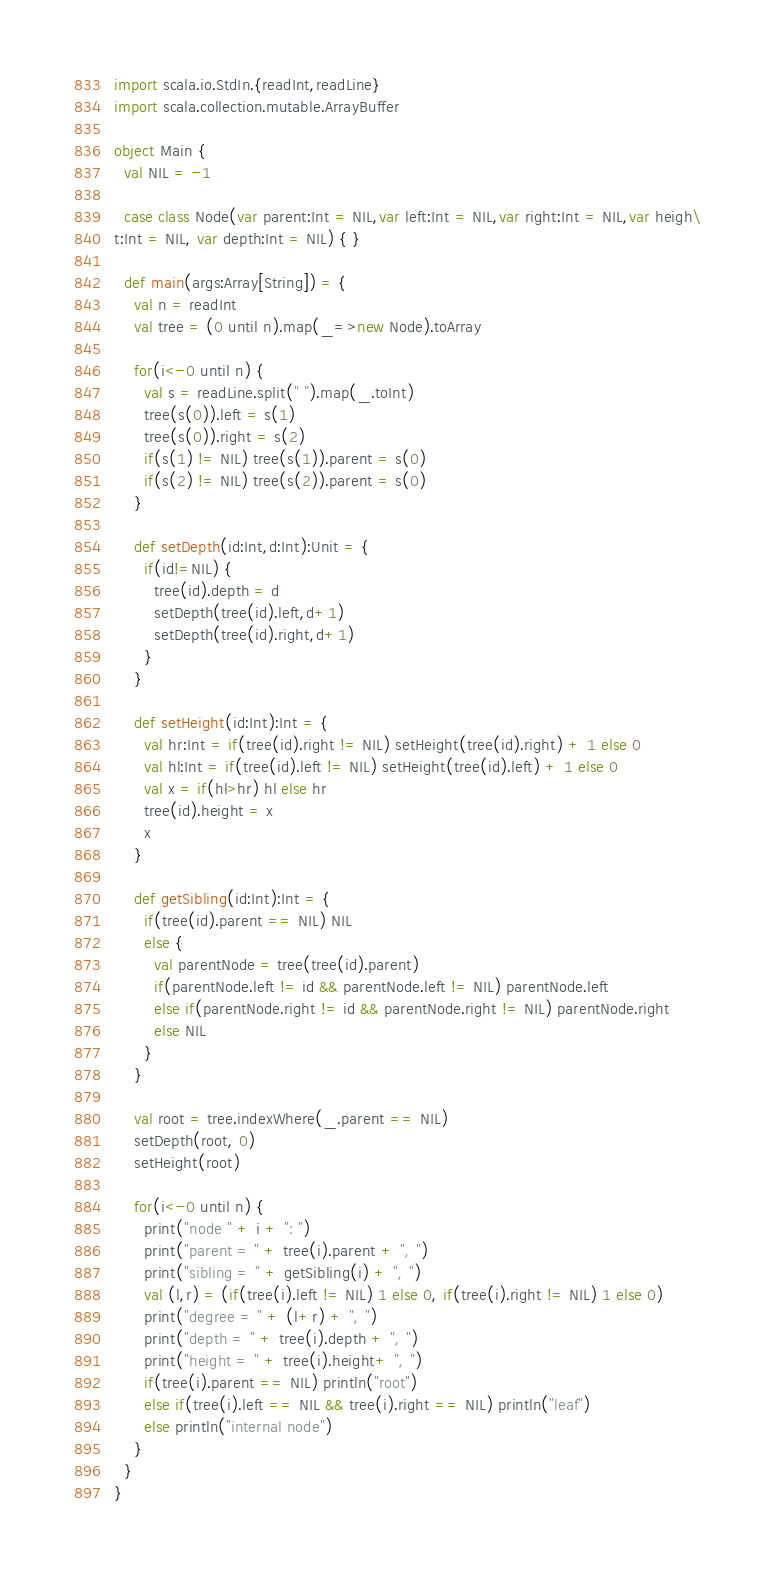Convert code to text. <code><loc_0><loc_0><loc_500><loc_500><_Scala_>import scala.io.StdIn.{readInt,readLine}
import scala.collection.mutable.ArrayBuffer

object Main {
  val NIL = -1

  case class Node(var parent:Int = NIL,var left:Int = NIL,var right:Int = NIL,var heigh\
t:Int = NIL, var depth:Int = NIL) { }

  def main(args:Array[String]) = {
    val n = readInt
    val tree = (0 until n).map(_=>new Node).toArray

    for(i<-0 until n) {
      val s = readLine.split(" ").map(_.toInt)
      tree(s(0)).left = s(1)
      tree(s(0)).right = s(2)
      if(s(1) != NIL) tree(s(1)).parent = s(0)
      if(s(2) != NIL) tree(s(2)).parent = s(0)
    }

    def setDepth(id:Int,d:Int):Unit = {
      if(id!=NIL) {
        tree(id).depth = d
        setDepth(tree(id).left,d+1)
        setDepth(tree(id).right,d+1)
      }
    }

    def setHeight(id:Int):Int = {
      val hr:Int = if(tree(id).right != NIL) setHeight(tree(id).right) + 1 else 0
      val hl:Int = if(tree(id).left != NIL) setHeight(tree(id).left) + 1 else 0
      val x = if(hl>hr) hl else hr
      tree(id).height = x
      x
    }

    def getSibling(id:Int):Int = {
      if(tree(id).parent == NIL) NIL
      else {
        val parentNode = tree(tree(id).parent)
        if(parentNode.left != id && parentNode.left != NIL) parentNode.left
        else if(parentNode.right != id && parentNode.right != NIL) parentNode.right
        else NIL
      }
    }

    val root = tree.indexWhere(_.parent == NIL)
    setDepth(root, 0)
    setHeight(root)

    for(i<-0 until n) {
      print("node " + i + ": ")
      print("parent = " + tree(i).parent + ", ")
      print("sibling = " + getSibling(i) + ", ")
      val (l,r) = (if(tree(i).left != NIL) 1 else 0, if(tree(i).right != NIL) 1 else 0)
      print("degree = " + (l+r) + ", ")
      print("depth = " + tree(i).depth + ", ")
      print("height = " + tree(i).height+ ", ")
      if(tree(i).parent == NIL) println("root")
      else if(tree(i).left == NIL && tree(i).right == NIL) println("leaf")
      else println("internal node")
    }
  }
}</code> 